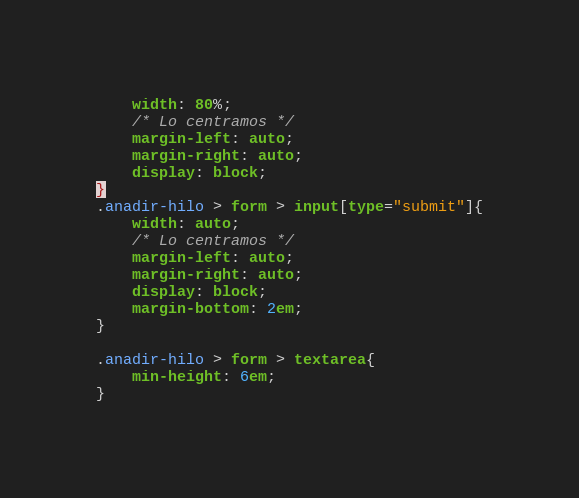<code> <loc_0><loc_0><loc_500><loc_500><_CSS_>	width: 80%; 
	/* Lo centramos */
	margin-left: auto;
	margin-right: auto;
	display: block;
}
.anadir-hilo > form > input[type="submit"]{
	width: auto;
	/* Lo centramos */
	margin-left: auto;
	margin-right: auto;
	display: block;
	margin-bottom: 2em; 
}

.anadir-hilo > form > textarea{
	min-height: 6em; 
}</code> 